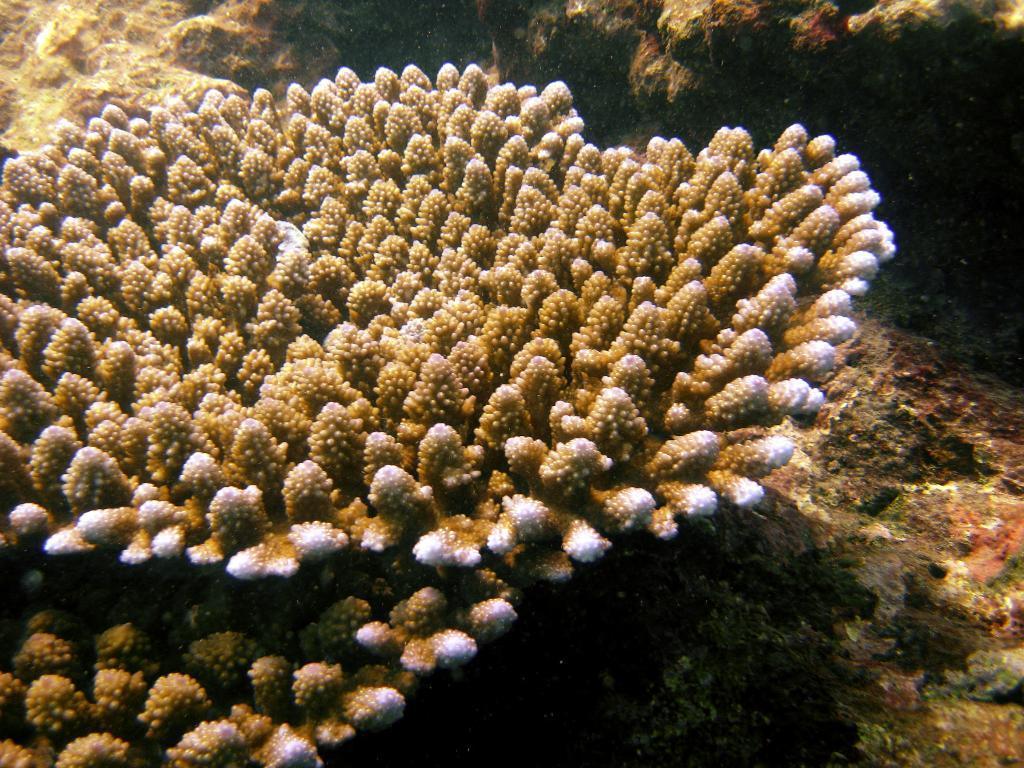Can you describe this image briefly? The image is taken inside water. In the image we can see coral reefs and plant. 